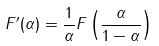<formula> <loc_0><loc_0><loc_500><loc_500>F ^ { \prime } ( \alpha ) = \frac { 1 } { \alpha } F \left ( \frac { \alpha } { 1 - \alpha } \right )</formula> 